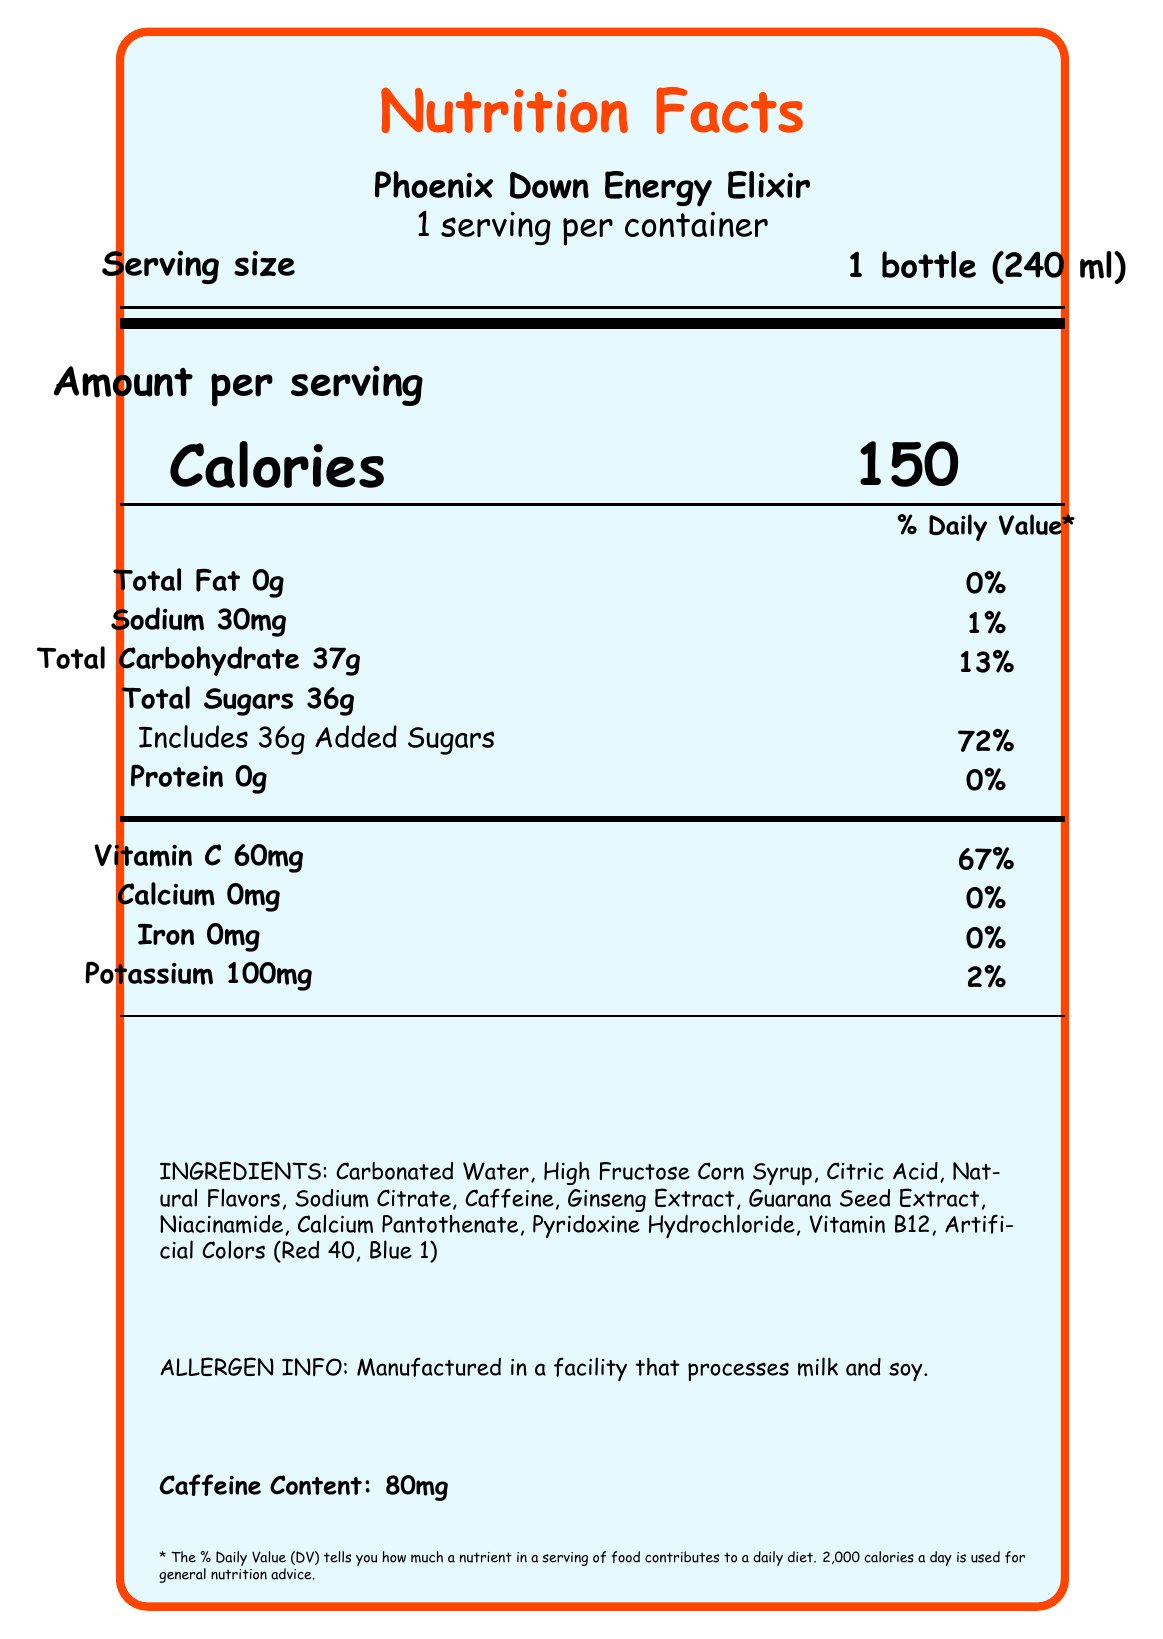what is the serving size of the Phoenix Down Energy Elixir? The serving size is mentioned as "1 bottle (240 ml)" in the document.
Answer: 1 bottle (240 ml) how many calories are there per serving? The document indicates that each serving contains 150 calories.
Answer: 150 what is the caffeine content of the elixir? The caffeine content is listed at the bottom of the document as 80mg.
Answer: 80mg how much sodium is in one serving of Phoenix Down Energy Elixir? The sodium content per serving is specified as 30mg.
Answer: 30mg what is the percentage daily value of added sugars in one serving? The document states that one serving contains 36g of added sugars, which is 72% of the daily value.
Answer: 72% how much vitamin C does one serving contain? A. 30mg B. 60mg C. 100mg D. 120mg The document specifies that one serving contains 60mg of Vitamin C.
Answer: B. 60mg what percent daily value of potassium does the elixir contain? A. 2% B. 5% C. 10% D. 15% The document states that one serving contains 2% of the daily value of potassium.
Answer: A. 2% is there any protein in the Phoenix Down Energy Elixir? The document indicates that the protein content is 0g, which means there is no protein.
Answer: No can we tell from the document if the elixir contains any Vitamin D? The document does not mention Vitamin D at all, so it is not possible to determine its presence or absence.
Answer: Cannot be determined describe the allergen information provided on the document. The allergen information states that the product is manufactured in a facility that processes milk and soy.
Answer: Manufactured in a facility that processes milk and soy. does the elixir contain any iron? The document lists the iron content as 0mg, therefore the elixir does not contain iron.
Answer: No what are the main ingredients of the Phoenix Down Energy Elixir? The ingredients are listed in a detailed section towards the bottom of the document.
Answer: Carbonated Water, High Fructose Corn Syrup, Citric Acid, Natural Flavors, Sodium Citrate, Caffeine, Ginseng Extract, Guarana Seed Extract, Niacinamide, Calcium Pantothenate, Pyridoxine Hydrochloride, Vitamin B12, Artificial Colors (Red 40, Blue 1) how many total designs are featured in the collectible series? The collection information mentions that there are 7 total designs.
Answer: 7 which artists are featured in the collectible series? The document lists these seven artists under the "collection_info" section.
Answer: Yoshitaka Amano, Tetsuya Nomura, Akihiko Yoshida, Yusuke Naora, Kazuma Kaneko, Shigenori Soejima, Takehito Harada summarize the marketing description of the Phoenix Down Energy Elixir. The document describes the energy elixir as a product to boost energy for gamers, featuring collectible artwork from famous JRPG artists and likened to the Phoenix Down item in Final Fantasy.
Answer: The Phoenix Down Energy Elixir is a limited-edition drink inspired by the iconic item from Final Fantasy, designed to revive your energy for gaming and anime sessions. It features collectible designs from legendary JRPG artists. how many daily servings does the document suggest? The document states that there is 1 serving per container, implying it is intended to be consumed in one session.
Answer: 1 